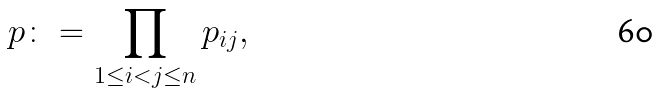<formula> <loc_0><loc_0><loc_500><loc_500>p \colon = \prod _ { 1 \leq i < j \leq n } p _ { i j } ,</formula> 